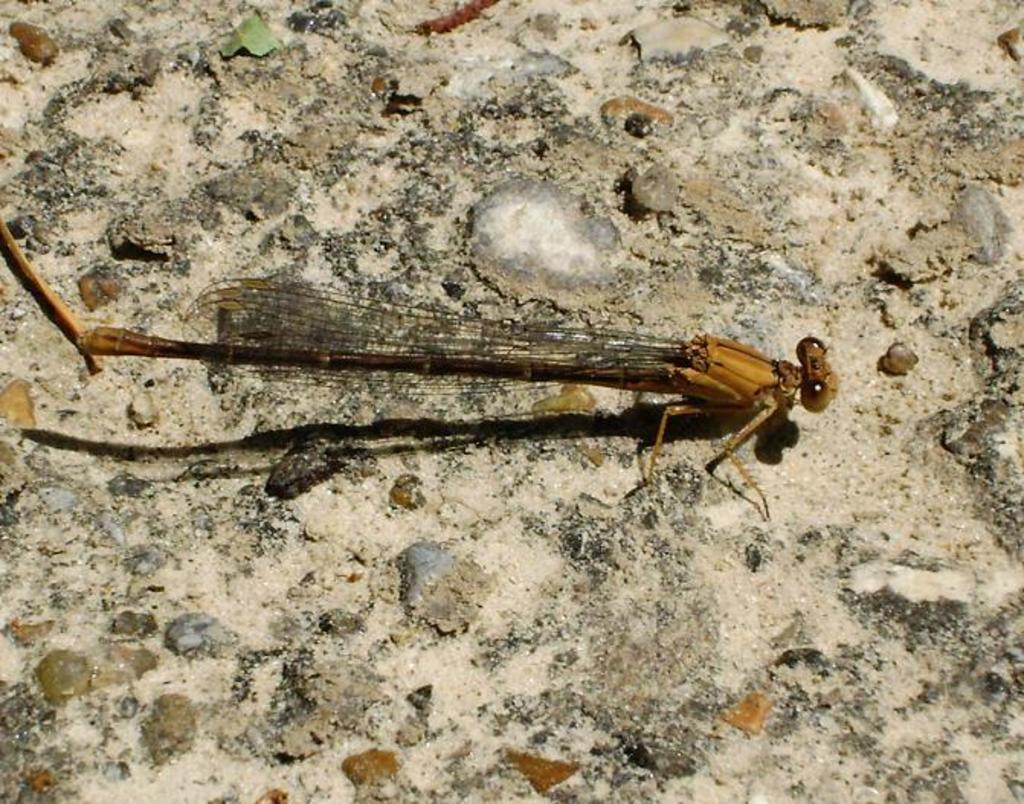What is depicted on the floor in the image? There is a dragonfly representation on the floor in the image. Where is the wren located in the image? There is no wren present in the image; it only features a dragonfly representation on the floor. 